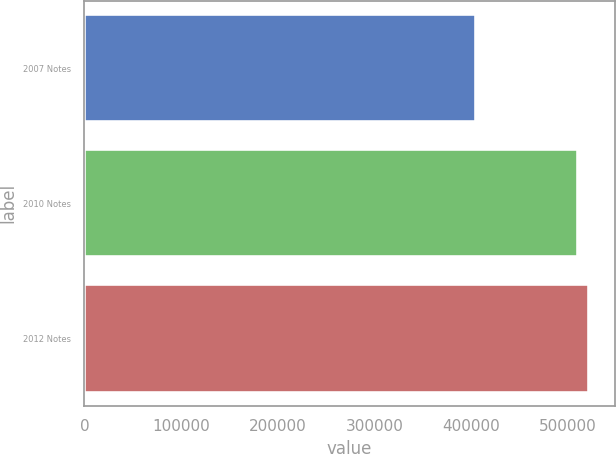Convert chart. <chart><loc_0><loc_0><loc_500><loc_500><bar_chart><fcel>2007 Notes<fcel>2010 Notes<fcel>2012 Notes<nl><fcel>405000<fcel>510800<fcel>522180<nl></chart> 